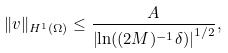Convert formula to latex. <formula><loc_0><loc_0><loc_500><loc_500>\| v \| _ { H ^ { 1 } ( \Omega ) } \leq \frac { A } { \left | \ln ( ( 2 M ) ^ { - 1 } \delta ) \right | ^ { 1 / 2 } } ,</formula> 